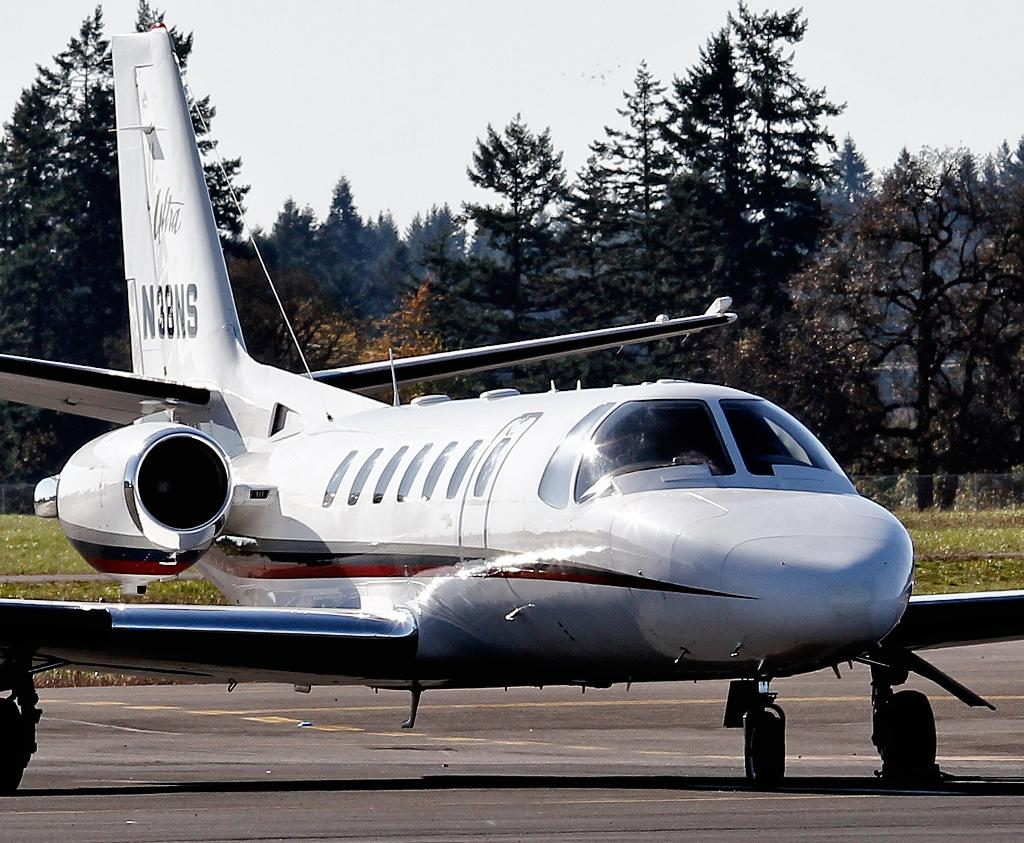<image>
Write a terse but informative summary of the picture. a parked plane with the ID N3BNS on it 